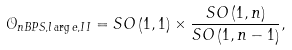<formula> <loc_0><loc_0><loc_500><loc_500>\mathcal { O } _ { n B P S , l \arg e , I I } = S O \left ( 1 , 1 \right ) \times \frac { S O \left ( 1 , n \right ) } { S O \left ( 1 , n - 1 \right ) } ,</formula> 